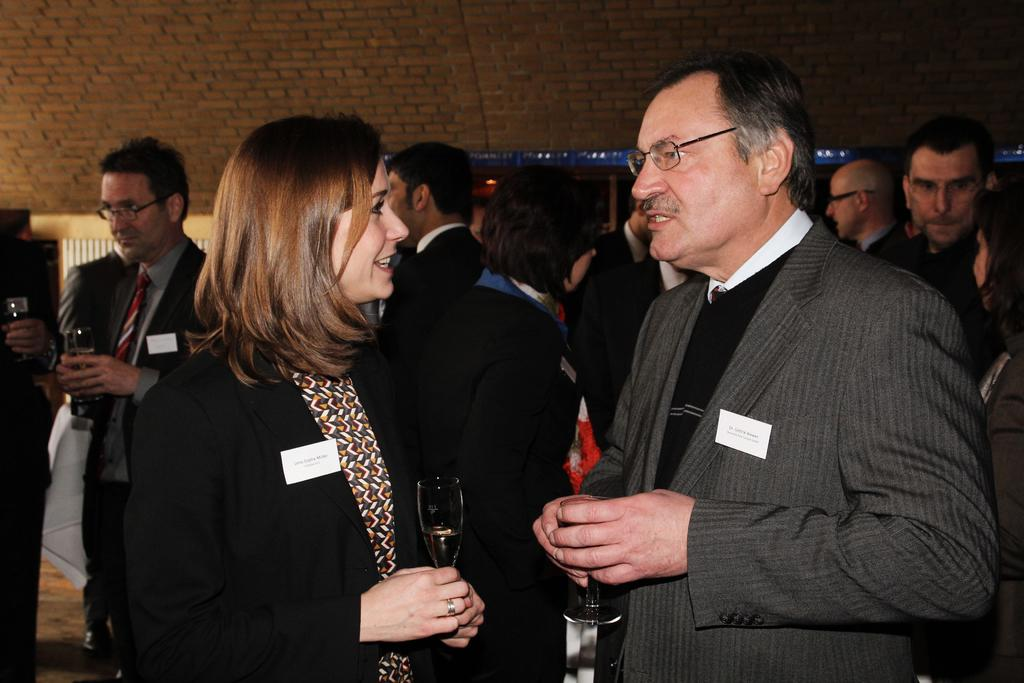What is happening in the image? There are people standing in the image. What are two of the people holding? Two people are holding glasses. What can be seen in the background of the image? There is a wall visible in the background of the image. What type of sweater is the person wearing in the image? There is no sweater mentioned or visible in the image. What does the bedroom look like in the image? There is no bedroom present in the image. 